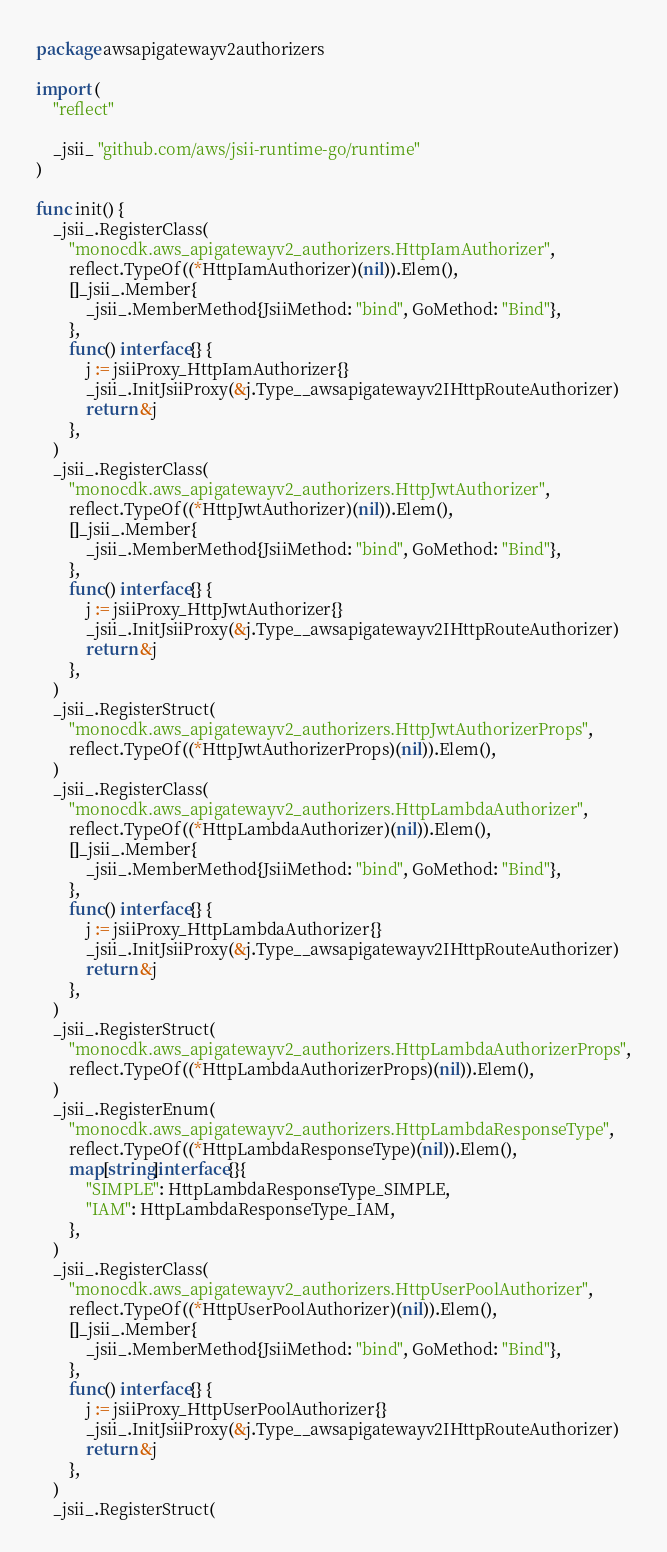Convert code to text. <code><loc_0><loc_0><loc_500><loc_500><_Go_>package awsapigatewayv2authorizers

import (
	"reflect"

	_jsii_ "github.com/aws/jsii-runtime-go/runtime"
)

func init() {
	_jsii_.RegisterClass(
		"monocdk.aws_apigatewayv2_authorizers.HttpIamAuthorizer",
		reflect.TypeOf((*HttpIamAuthorizer)(nil)).Elem(),
		[]_jsii_.Member{
			_jsii_.MemberMethod{JsiiMethod: "bind", GoMethod: "Bind"},
		},
		func() interface{} {
			j := jsiiProxy_HttpIamAuthorizer{}
			_jsii_.InitJsiiProxy(&j.Type__awsapigatewayv2IHttpRouteAuthorizer)
			return &j
		},
	)
	_jsii_.RegisterClass(
		"monocdk.aws_apigatewayv2_authorizers.HttpJwtAuthorizer",
		reflect.TypeOf((*HttpJwtAuthorizer)(nil)).Elem(),
		[]_jsii_.Member{
			_jsii_.MemberMethod{JsiiMethod: "bind", GoMethod: "Bind"},
		},
		func() interface{} {
			j := jsiiProxy_HttpJwtAuthorizer{}
			_jsii_.InitJsiiProxy(&j.Type__awsapigatewayv2IHttpRouteAuthorizer)
			return &j
		},
	)
	_jsii_.RegisterStruct(
		"monocdk.aws_apigatewayv2_authorizers.HttpJwtAuthorizerProps",
		reflect.TypeOf((*HttpJwtAuthorizerProps)(nil)).Elem(),
	)
	_jsii_.RegisterClass(
		"monocdk.aws_apigatewayv2_authorizers.HttpLambdaAuthorizer",
		reflect.TypeOf((*HttpLambdaAuthorizer)(nil)).Elem(),
		[]_jsii_.Member{
			_jsii_.MemberMethod{JsiiMethod: "bind", GoMethod: "Bind"},
		},
		func() interface{} {
			j := jsiiProxy_HttpLambdaAuthorizer{}
			_jsii_.InitJsiiProxy(&j.Type__awsapigatewayv2IHttpRouteAuthorizer)
			return &j
		},
	)
	_jsii_.RegisterStruct(
		"monocdk.aws_apigatewayv2_authorizers.HttpLambdaAuthorizerProps",
		reflect.TypeOf((*HttpLambdaAuthorizerProps)(nil)).Elem(),
	)
	_jsii_.RegisterEnum(
		"monocdk.aws_apigatewayv2_authorizers.HttpLambdaResponseType",
		reflect.TypeOf((*HttpLambdaResponseType)(nil)).Elem(),
		map[string]interface{}{
			"SIMPLE": HttpLambdaResponseType_SIMPLE,
			"IAM": HttpLambdaResponseType_IAM,
		},
	)
	_jsii_.RegisterClass(
		"monocdk.aws_apigatewayv2_authorizers.HttpUserPoolAuthorizer",
		reflect.TypeOf((*HttpUserPoolAuthorizer)(nil)).Elem(),
		[]_jsii_.Member{
			_jsii_.MemberMethod{JsiiMethod: "bind", GoMethod: "Bind"},
		},
		func() interface{} {
			j := jsiiProxy_HttpUserPoolAuthorizer{}
			_jsii_.InitJsiiProxy(&j.Type__awsapigatewayv2IHttpRouteAuthorizer)
			return &j
		},
	)
	_jsii_.RegisterStruct(</code> 